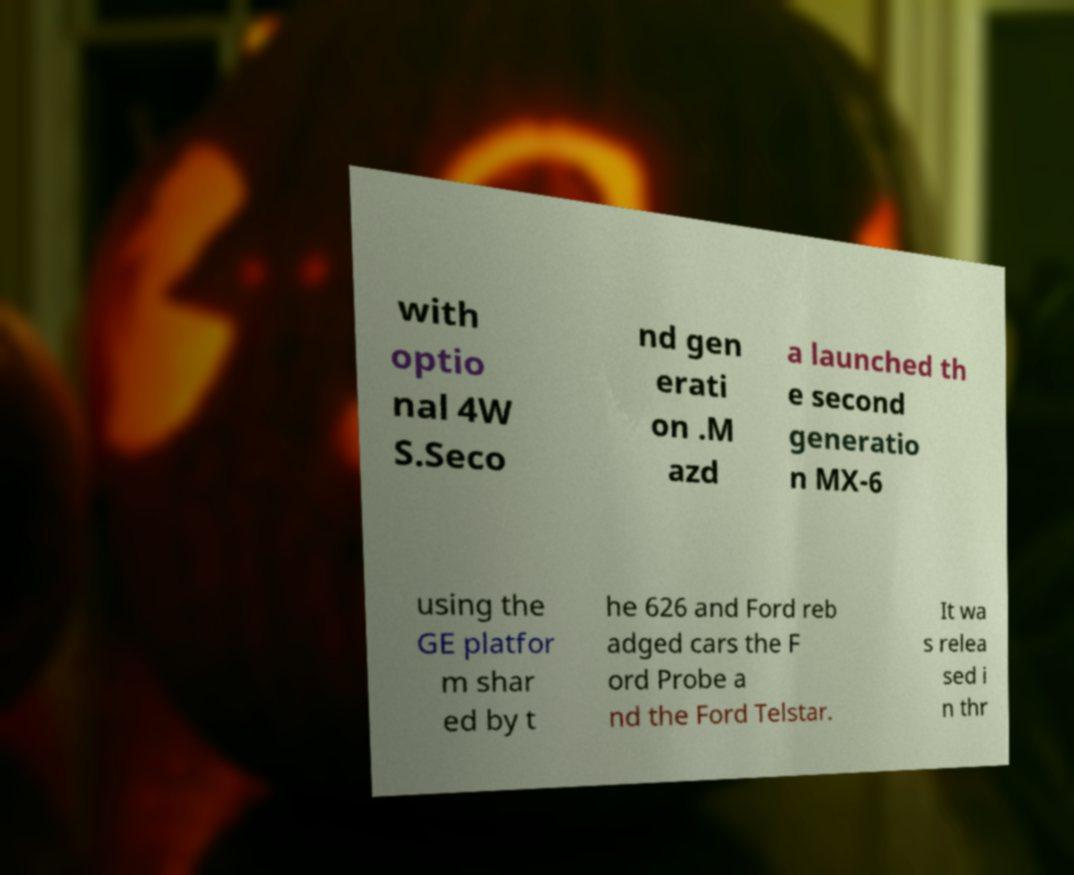Please read and relay the text visible in this image. What does it say? with optio nal 4W S.Seco nd gen erati on .M azd a launched th e second generatio n MX-6 using the GE platfor m shar ed by t he 626 and Ford reb adged cars the F ord Probe a nd the Ford Telstar. It wa s relea sed i n thr 